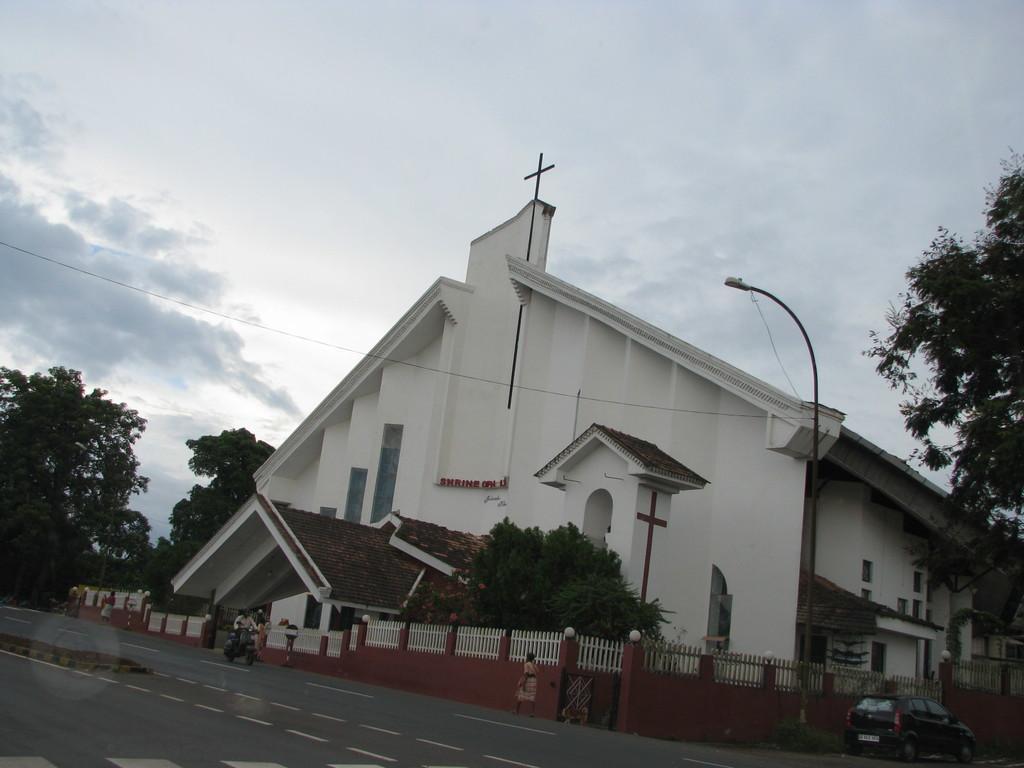How would you summarize this image in a sentence or two? In this picture there is a building and there are trees and there is a street light and there is text on the wall. In the foreground there is a wooden railing on the wall and there are group of people walking and there is a person riding motor bike on the road and there is a car on the road. At the top there is sky and there are clouds. At the bottom there is a road. 